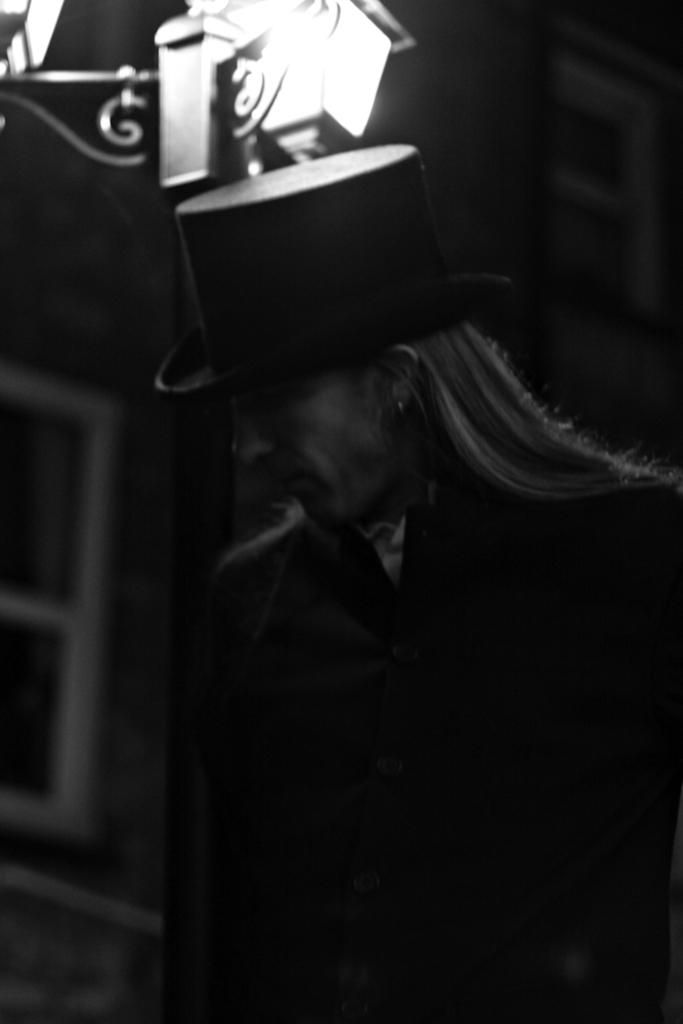What is the main subject of the image? There is a person in the image. What is the person wearing on their head? The person is wearing a hat. What type of clothing is the person wearing? The person is wearing a suit. Can you describe the light at the bottom of the image? There is a light at the bottom of the image. What type of bead is the person holding in the image? There is no bead present in the image. What songs is the person singing in the image? There is no indication in the image that the person is singing any songs. 